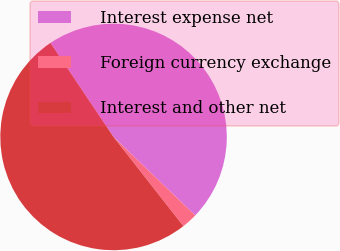<chart> <loc_0><loc_0><loc_500><loc_500><pie_chart><fcel>Interest expense net<fcel>Foreign currency exchange<fcel>Interest and other net<nl><fcel>46.59%<fcel>2.24%<fcel>51.17%<nl></chart> 